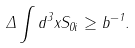<formula> <loc_0><loc_0><loc_500><loc_500>\Delta \int d ^ { 3 } x S _ { 0 i } \geq b ^ { - 1 } .</formula> 